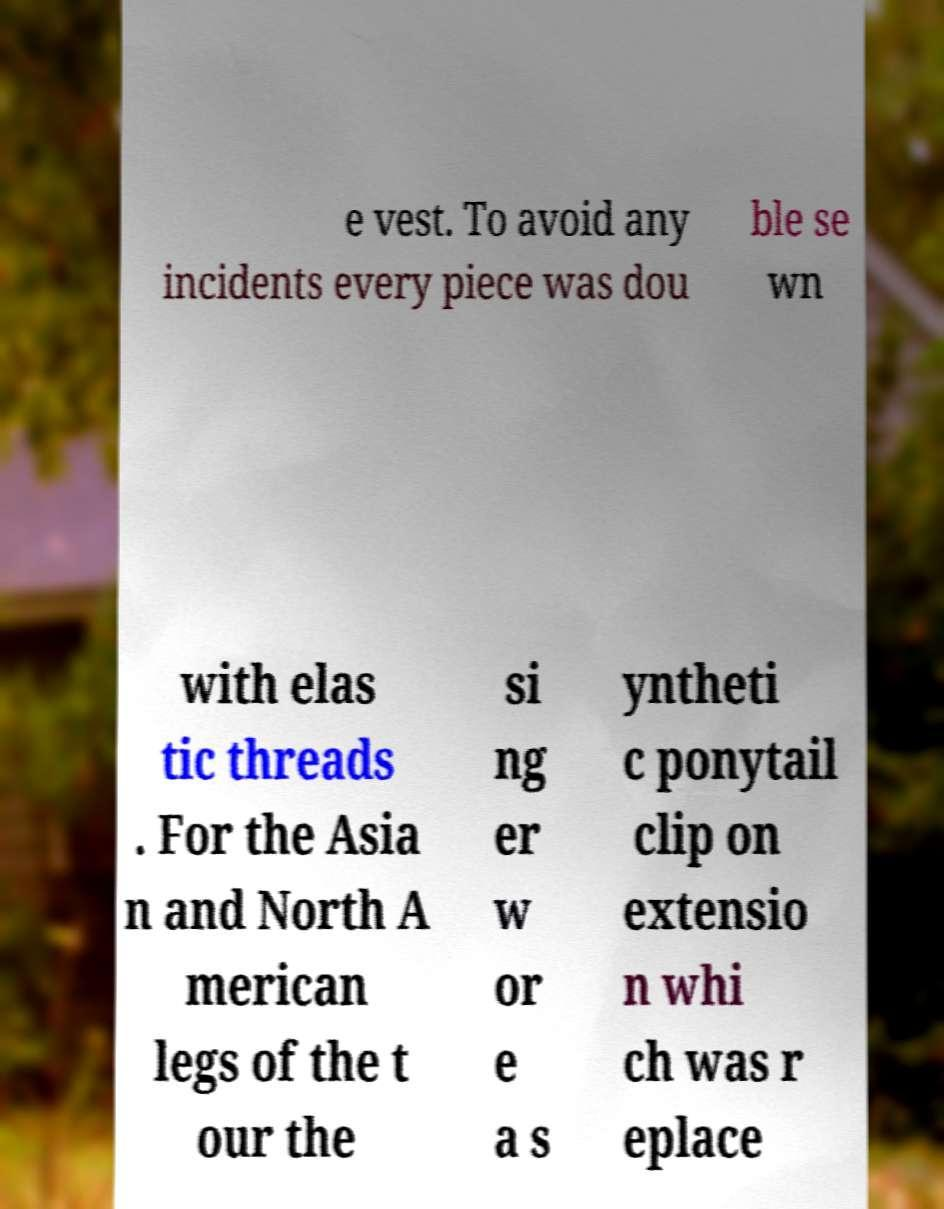There's text embedded in this image that I need extracted. Can you transcribe it verbatim? e vest. To avoid any incidents every piece was dou ble se wn with elas tic threads . For the Asia n and North A merican legs of the t our the si ng er w or e a s yntheti c ponytail clip on extensio n whi ch was r eplace 